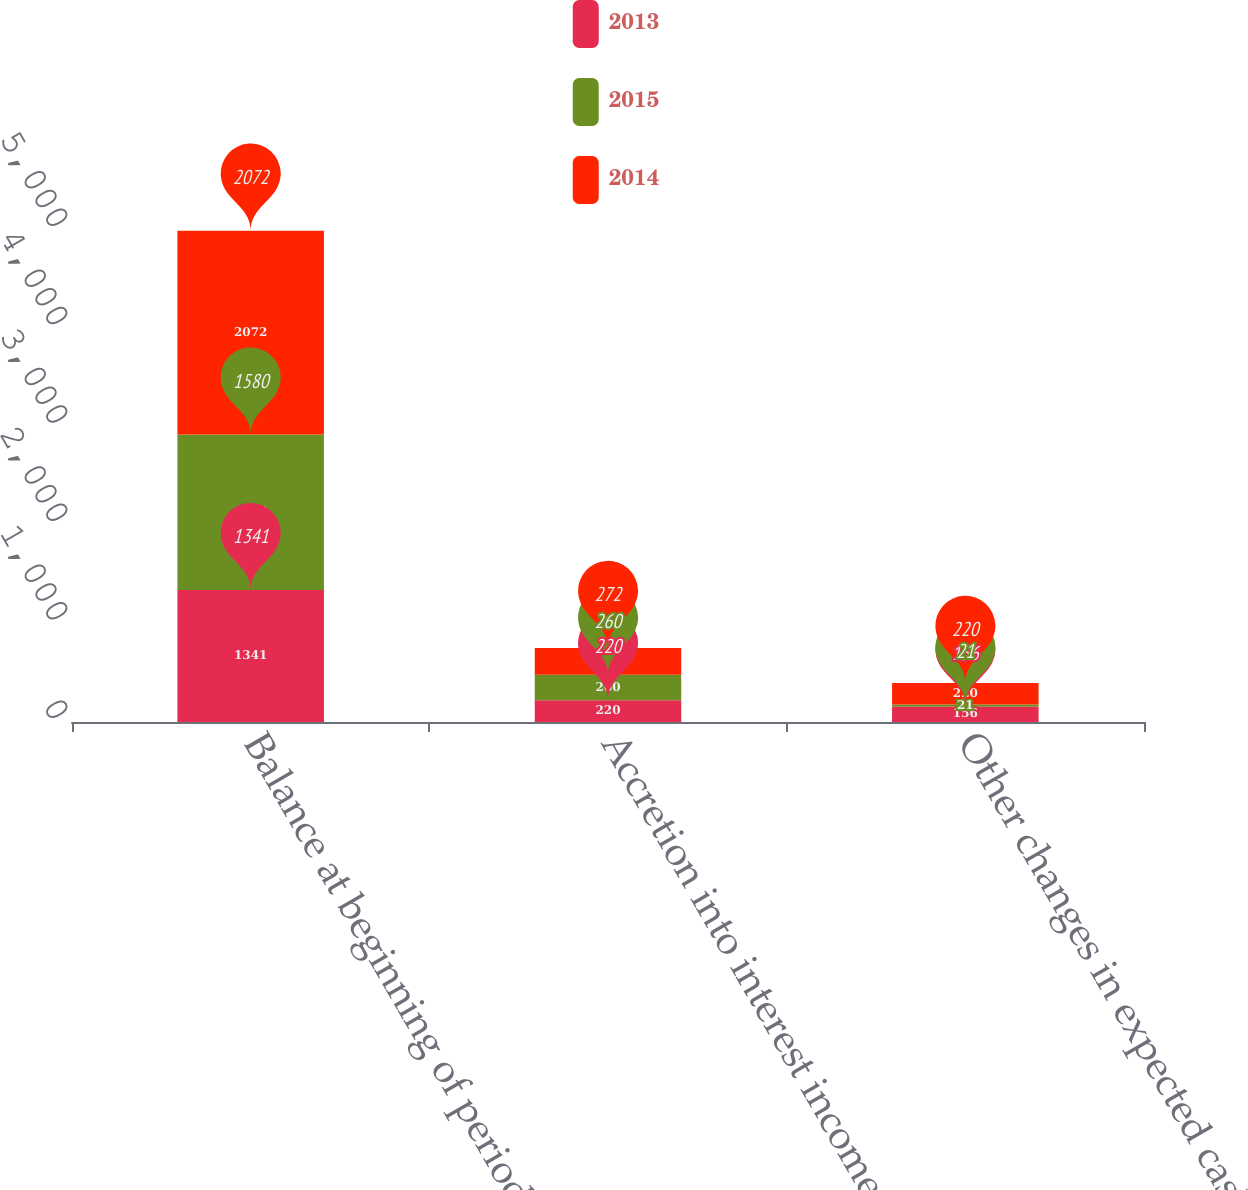<chart> <loc_0><loc_0><loc_500><loc_500><stacked_bar_chart><ecel><fcel>Balance at beginning of period<fcel>Accretion into interest income<fcel>Other changes in expected cash<nl><fcel>2013<fcel>1341<fcel>220<fcel>156<nl><fcel>2015<fcel>1580<fcel>260<fcel>21<nl><fcel>2014<fcel>2072<fcel>272<fcel>220<nl></chart> 